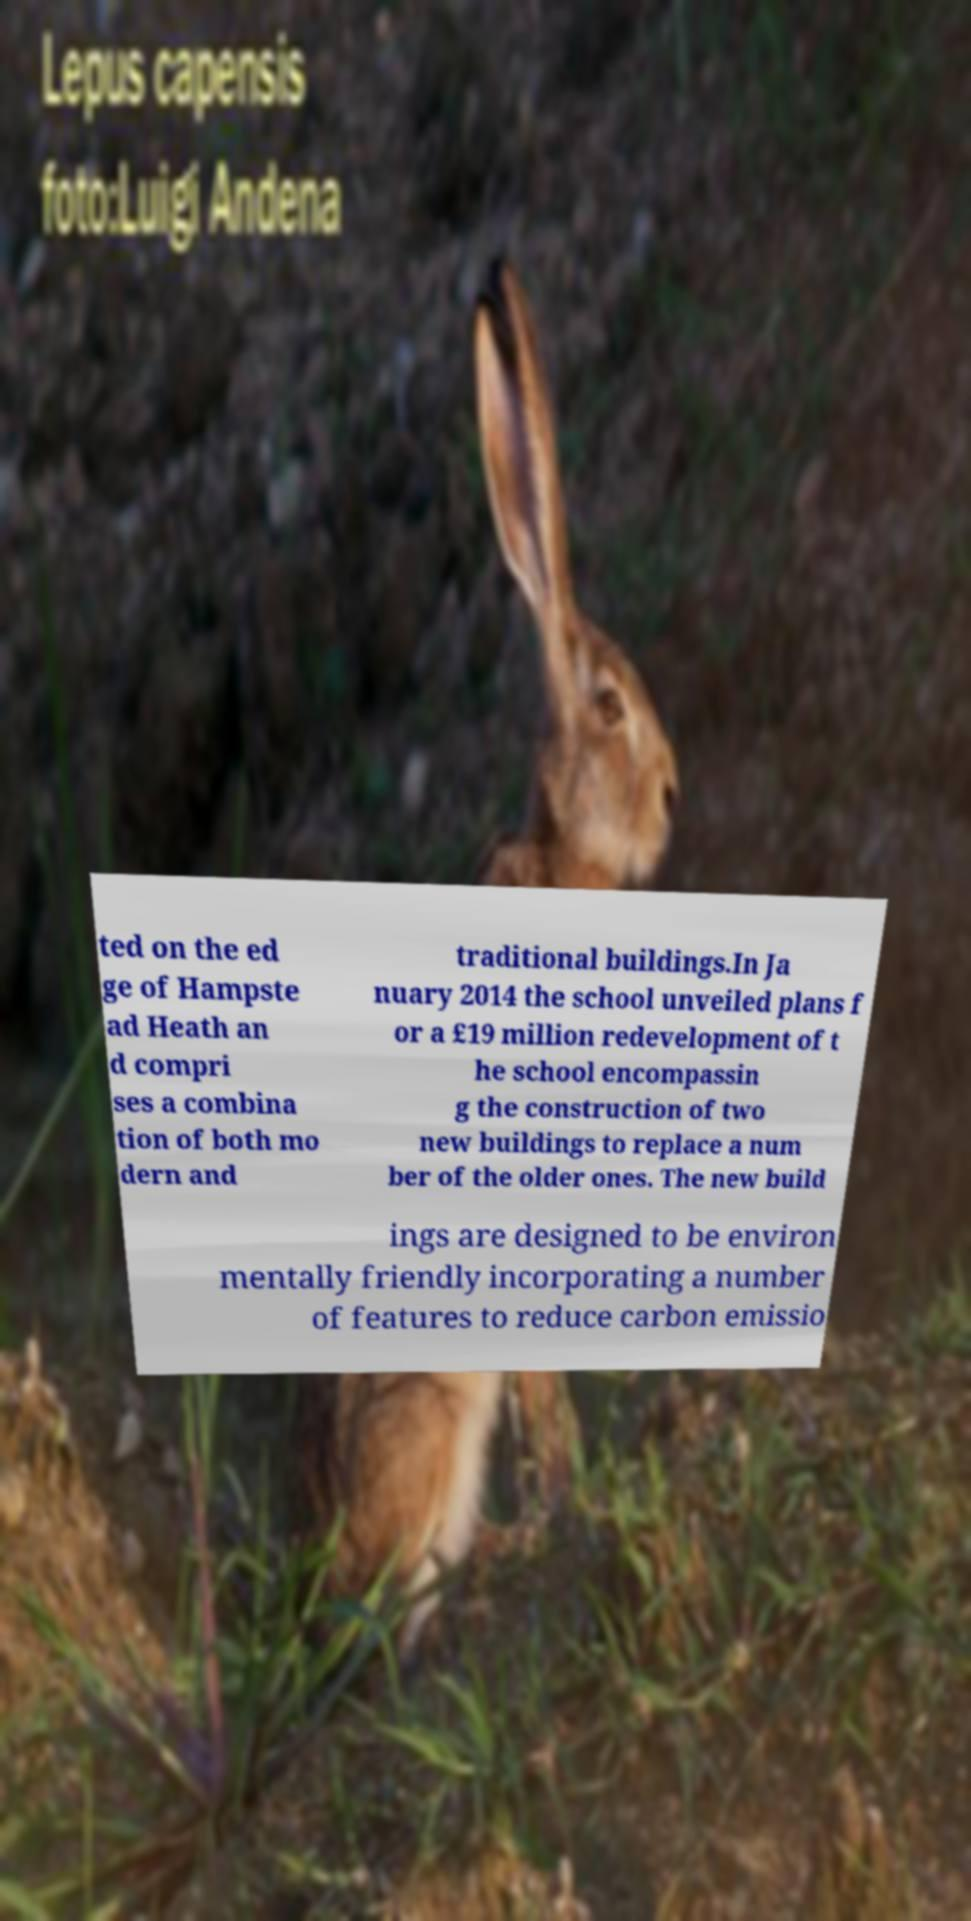Could you assist in decoding the text presented in this image and type it out clearly? ted on the ed ge of Hampste ad Heath an d compri ses a combina tion of both mo dern and traditional buildings.In Ja nuary 2014 the school unveiled plans f or a £19 million redevelopment of t he school encompassin g the construction of two new buildings to replace a num ber of the older ones. The new build ings are designed to be environ mentally friendly incorporating a number of features to reduce carbon emissio 